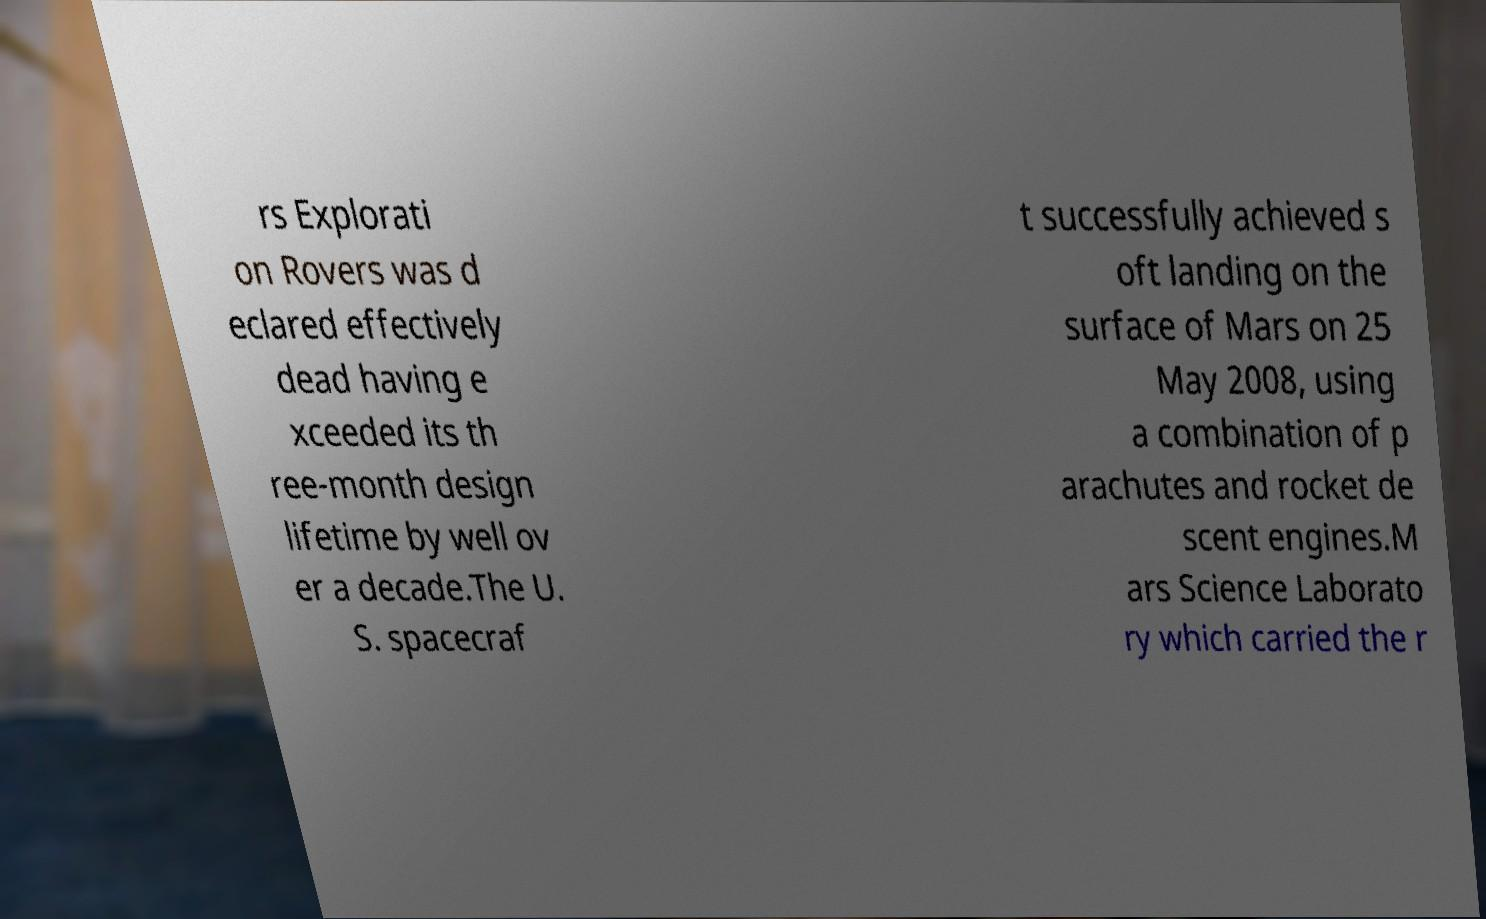Could you extract and type out the text from this image? rs Explorati on Rovers was d eclared effectively dead having e xceeded its th ree-month design lifetime by well ov er a decade.The U. S. spacecraf t successfully achieved s oft landing on the surface of Mars on 25 May 2008, using a combination of p arachutes and rocket de scent engines.M ars Science Laborato ry which carried the r 